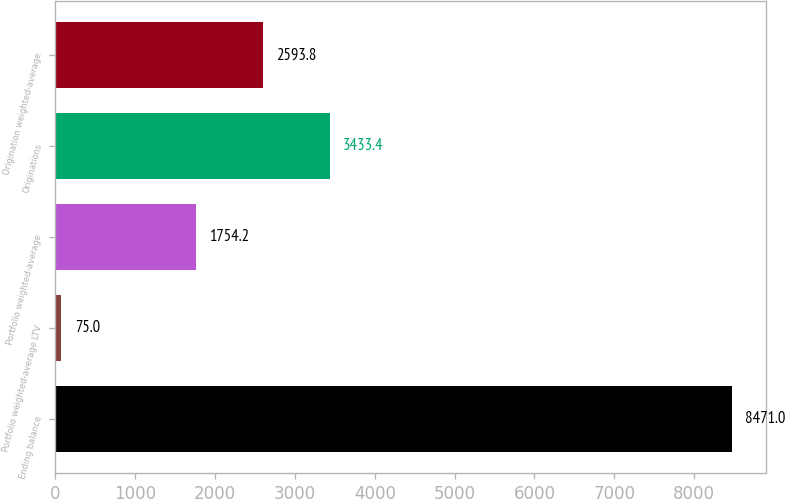<chart> <loc_0><loc_0><loc_500><loc_500><bar_chart><fcel>Ending balance<fcel>Portfolio weighted-average LTV<fcel>Portfolio weighted-average<fcel>Originations<fcel>Origination weighted-average<nl><fcel>8471<fcel>75<fcel>1754.2<fcel>3433.4<fcel>2593.8<nl></chart> 